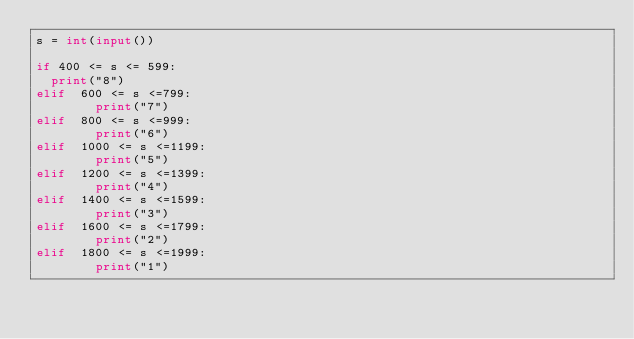<code> <loc_0><loc_0><loc_500><loc_500><_Python_>s = int(input()) 
 
if 400 <= s <= 599:
  print("8")
elif  600 <= s <=799:
        print("7")
elif  800 <= s <=999:
        print("6")
elif  1000 <= s <=1199:
        print("5")
elif  1200 <= s <=1399:
        print("4")
elif  1400 <= s <=1599:
        print("3")
elif  1600 <= s <=1799:
        print("2")
elif  1800 <= s <=1999:
        print("1")</code> 